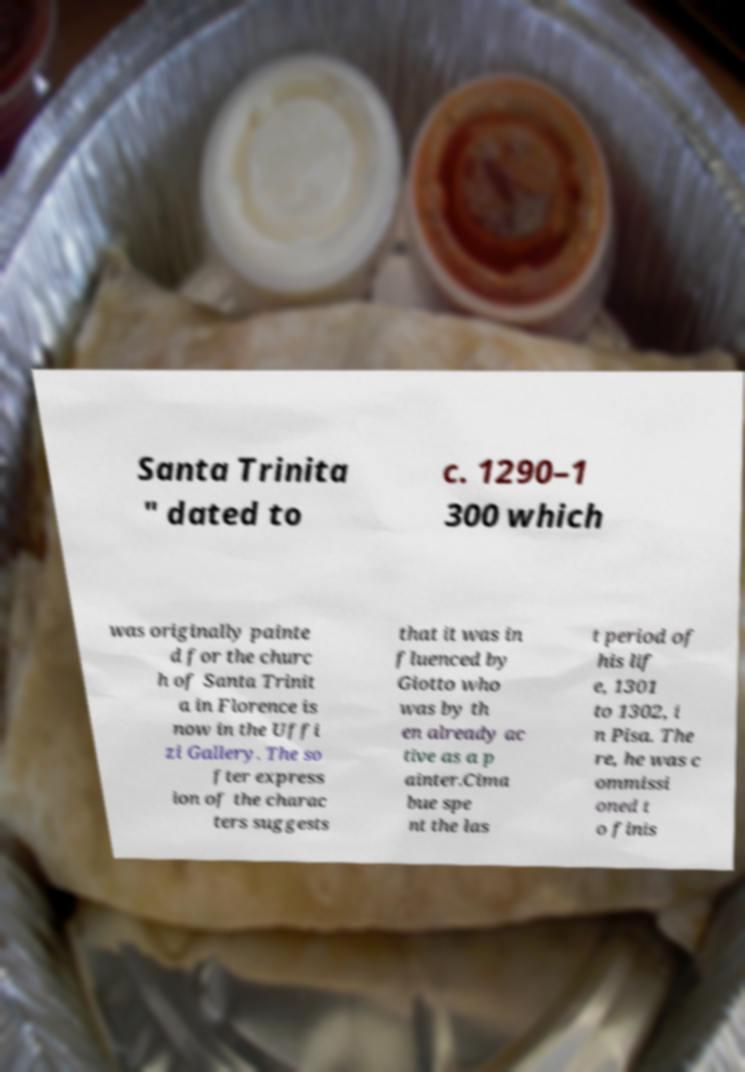Please read and relay the text visible in this image. What does it say? Santa Trinita " dated to c. 1290–1 300 which was originally painte d for the churc h of Santa Trinit a in Florence is now in the Uffi zi Gallery. The so fter express ion of the charac ters suggests that it was in fluenced by Giotto who was by th en already ac tive as a p ainter.Cima bue spe nt the las t period of his lif e, 1301 to 1302, i n Pisa. The re, he was c ommissi oned t o finis 